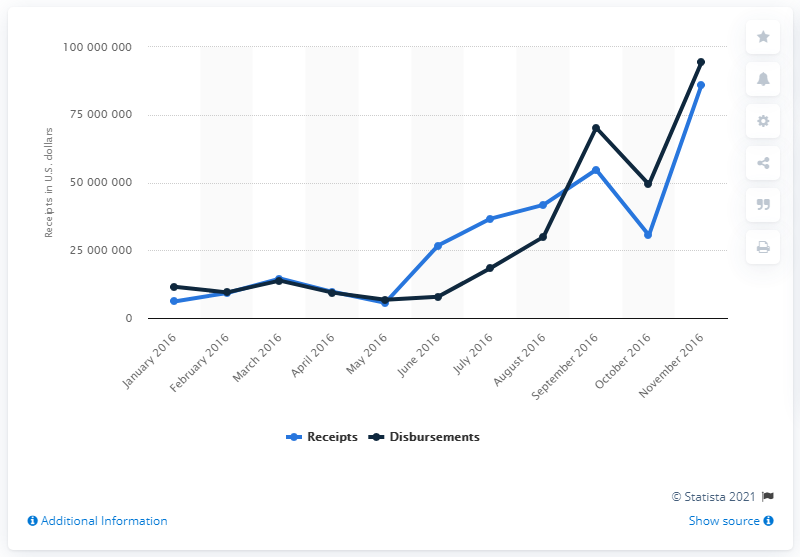Specify some key components in this picture. Donald Trump's 2016 presidential campaign received a total of $8,610,566.41. 